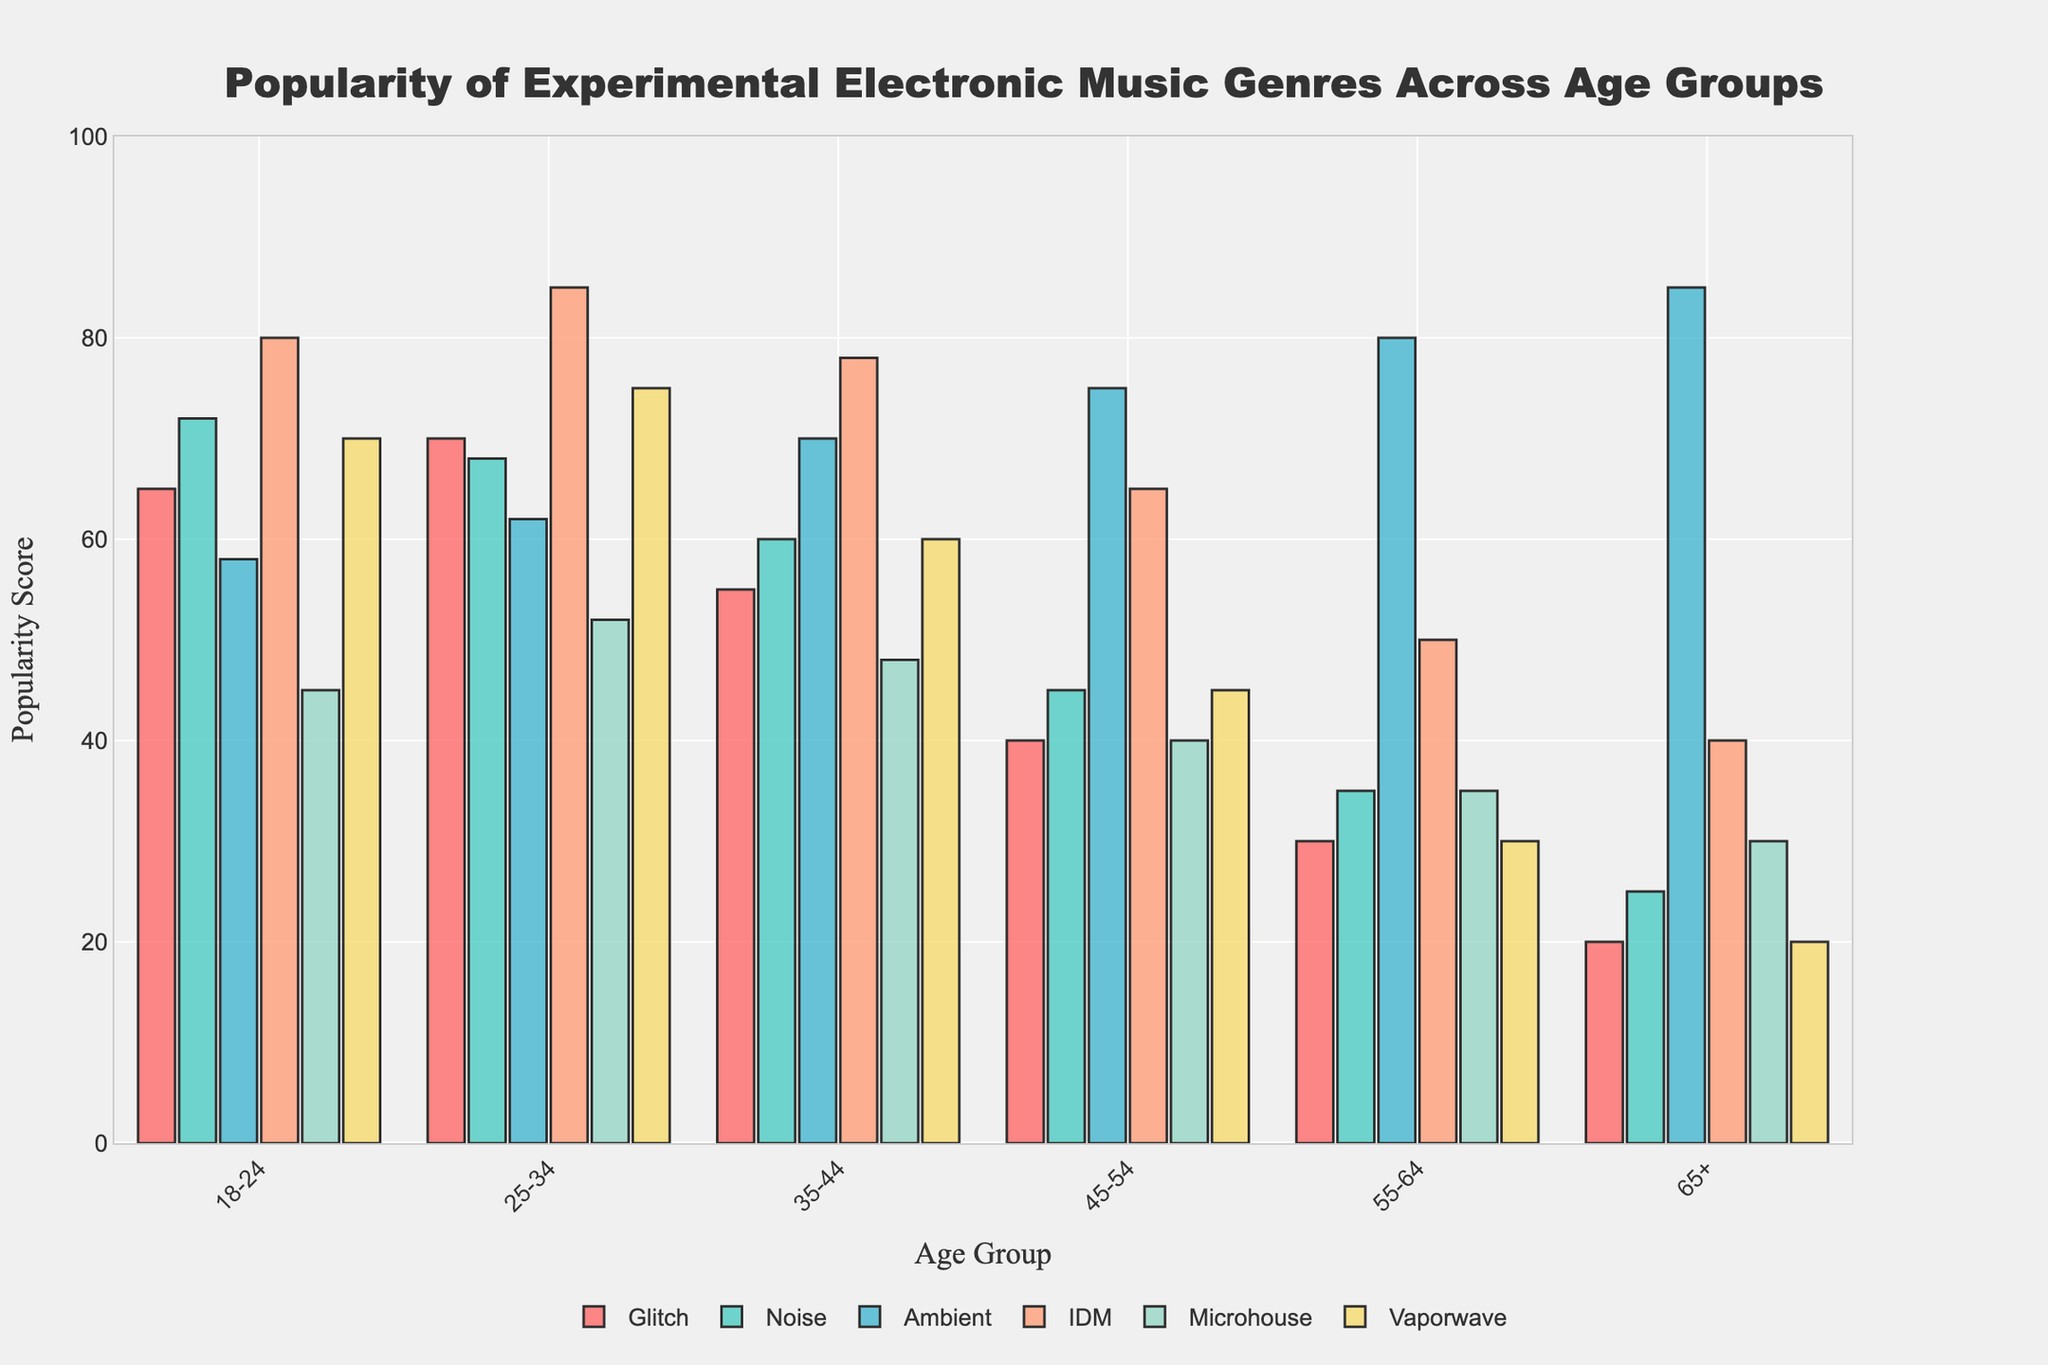Which age group finds Ambient music the most popular? Look for the bar with the highest value in the Ambient music category and locate its corresponding age group. The highest bar for Ambient is 85, corresponding to the 65+ age group.
Answer: 65+ How does the popularity of IDM music vary between the 18-24 and 55-64 age groups? Compare the bar heights for IDM music for these two age groups. For 18-24, it is 80, while for 55-64, it is 50.
Answer: 80 vs 50 Which genre is the least popular among the 45-54 age group? Identify the shortest bar among all genres for the 45-54 age group. The shortest bar is the Noise genre, which is 45.
Answer: Noise What is the sum of the popularity scores for Microhouse music across all age groups? Add up the values of Microhouse music for all age groups: 45 (18-24) + 52 (25-34) + 48 (35-44) + 40 (45-54) + 35 (55-64) + 30 (65+)= 250
Answer: 250 Which genre has a consistently increasing or decreasing trend across age groups? Examine each genre's bars to identify if they continuously increase or decrease in height from youngest to oldest. Ambient music has an increasing trend from 58 (18-24) to 85 (65+).
Answer: Ambient Between the age groups 25-34 and 35-44, which has a higher preference for Glitch music? Compare the bar heights for Glitch music for these two age groups. For 25-34, it is 70; for 35-44, it is 55.
Answer: 25-34 Calculate the average popularity of Vaporwave music across all age groups. Sum the Vaporwave values across all age groups and divide by the number of age groups: (70 + 75 + 60 + 45 + 30 + 20) / 6 = 50
Answer: 50 How does the popularity of Noise music for the 35-44 age group compare to that for the 18-24 age group? Compare the bar heights for Noise music for these two age groups. For 35-44, it is 60; for 18-24, it is 72.
Answer: Higher for 18-24 Which age group shows the least preference for all the genres combined? Sum the popularity scores for each age group and find the group with the lowest total. Adding up scores: 
18-24: 65+72+58+80+45+70 = 390
25-34: 70+68+62+85+52+75 = 412
35-44: 55+60+70+78+48+60 = 371
45-54: 40+45+75+65+40+45 = 310
55-64: 30+35+80+50+35+30 = 260
65+: 20+25+85+40+30+20 = 220
Answer: 65+ Which age group shows the highest popularity score for Microhouse music? Look for the highest bar in the Microhouse music category and find the corresponding age group. The highest bar for Microhouse is 52, corresponding to the 25-34 age group.
Answer: 25-34 